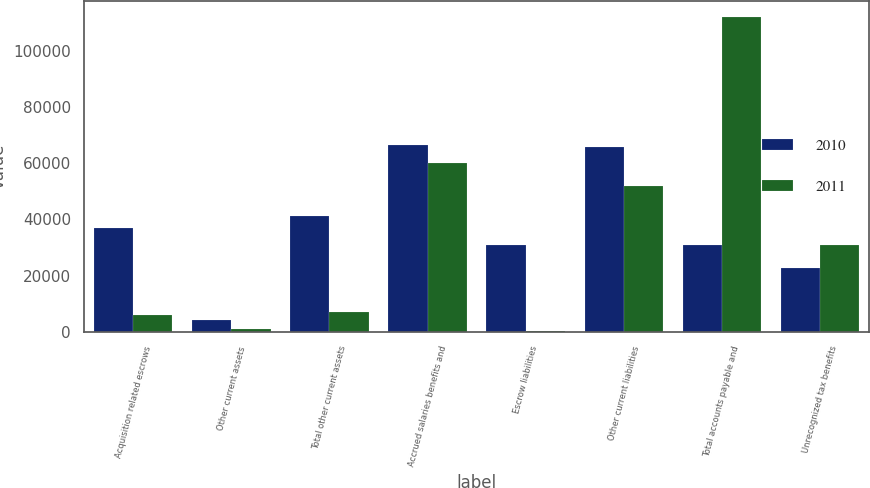<chart> <loc_0><loc_0><loc_500><loc_500><stacked_bar_chart><ecel><fcel>Acquisition related escrows<fcel>Other current assets<fcel>Total other current assets<fcel>Accrued salaries benefits and<fcel>Escrow liabilities<fcel>Other current liabilities<fcel>Total accounts payable and<fcel>Unrecognized tax benefits<nl><fcel>2010<fcel>36967<fcel>4281<fcel>41248<fcel>66354<fcel>30899<fcel>65739<fcel>30899<fcel>22567<nl><fcel>2011<fcel>6167<fcel>899<fcel>7066<fcel>60013<fcel>135<fcel>51847<fcel>111995<fcel>30833<nl></chart> 